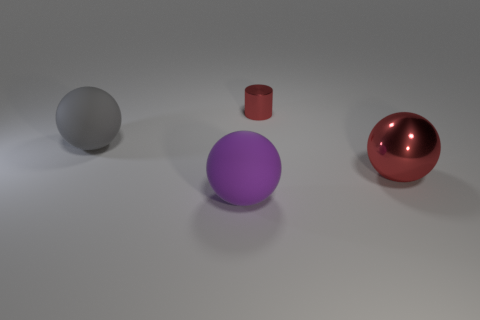Subtract all purple balls. How many balls are left? 2 Subtract all purple balls. How many balls are left? 2 Add 2 rubber objects. How many objects exist? 6 Subtract all balls. How many objects are left? 1 Subtract all purple spheres. Subtract all green blocks. How many spheres are left? 2 Subtract all yellow cylinders. How many gray spheres are left? 1 Subtract all large purple matte spheres. Subtract all purple balls. How many objects are left? 2 Add 3 tiny red metallic cylinders. How many tiny red metallic cylinders are left? 4 Add 3 shiny objects. How many shiny objects exist? 5 Subtract 1 red balls. How many objects are left? 3 